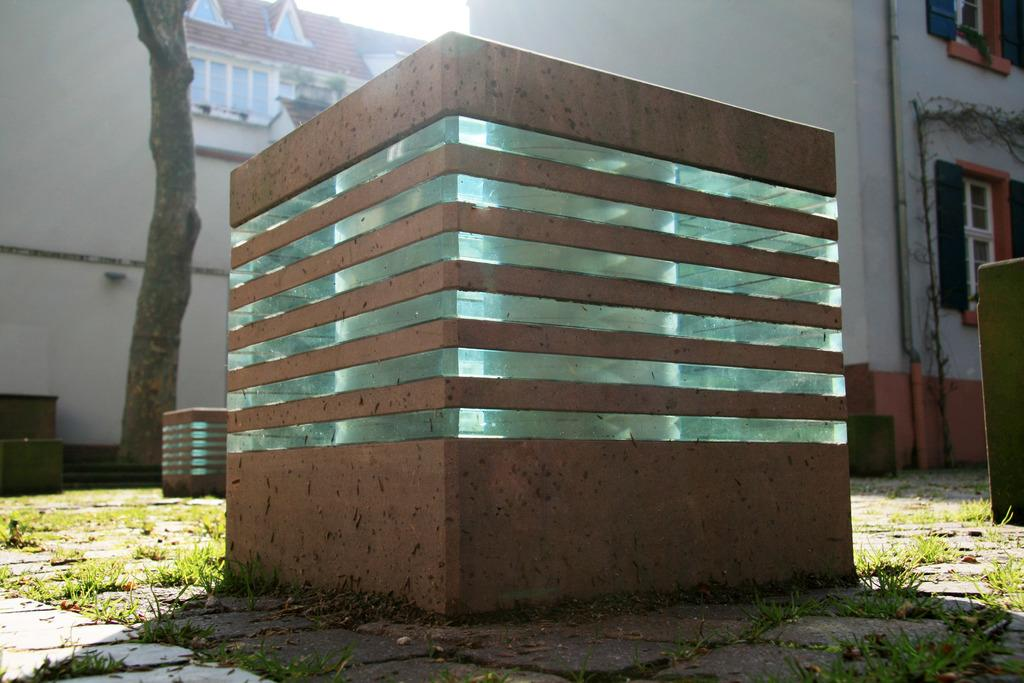What type of lights are present in the image? There are garden fixture lights in the image. Where are the lights placed? The lights are placed on the ground. What can be seen in the background of the image? There is a building, windows, and a tree trunk visible in the background of the image. What type of glass is being used to sing a song in the image? There is no glass or singing in the image; it features garden fixture lights placed on the ground and a background with a building, windows, and a tree trunk. 